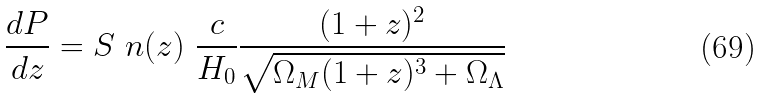Convert formula to latex. <formula><loc_0><loc_0><loc_500><loc_500>\frac { d P } { d z } = S \ n ( z ) \ \frac { c } { H _ { 0 } } \frac { ( 1 + z ) ^ { 2 } } { \sqrt { \Omega _ { M } ( 1 + z ) ^ { 3 } + \Omega _ { \Lambda } } }</formula> 